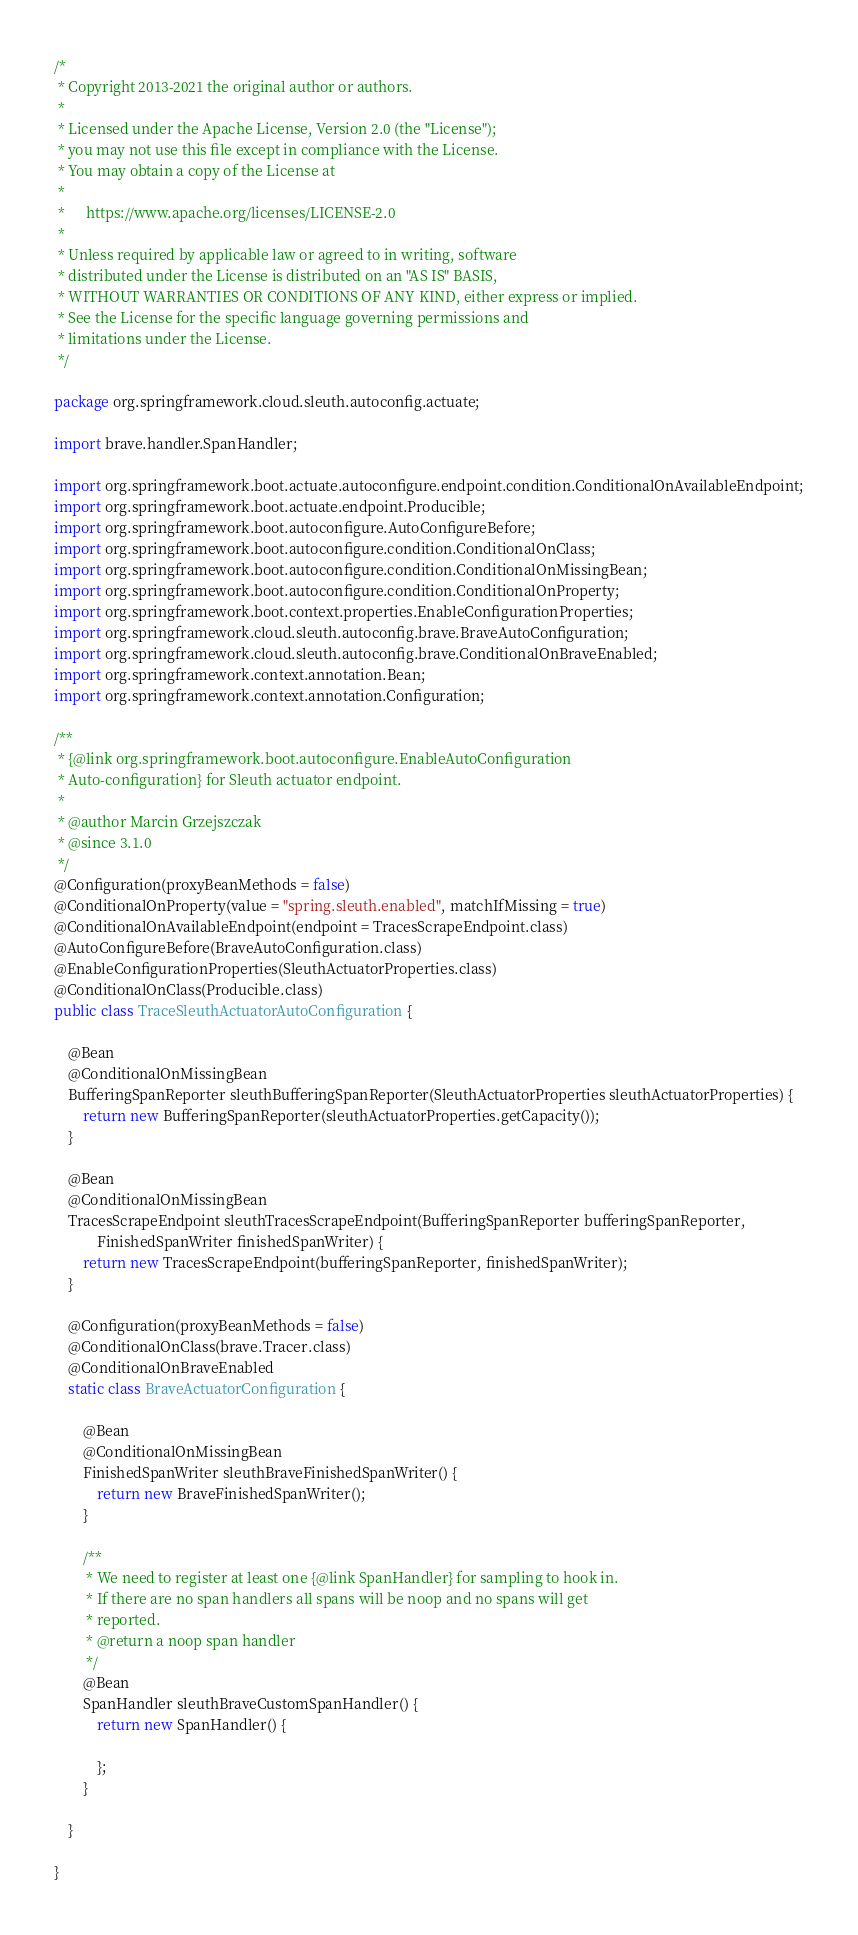Convert code to text. <code><loc_0><loc_0><loc_500><loc_500><_Java_>/*
 * Copyright 2013-2021 the original author or authors.
 *
 * Licensed under the Apache License, Version 2.0 (the "License");
 * you may not use this file except in compliance with the License.
 * You may obtain a copy of the License at
 *
 *      https://www.apache.org/licenses/LICENSE-2.0
 *
 * Unless required by applicable law or agreed to in writing, software
 * distributed under the License is distributed on an "AS IS" BASIS,
 * WITHOUT WARRANTIES OR CONDITIONS OF ANY KIND, either express or implied.
 * See the License for the specific language governing permissions and
 * limitations under the License.
 */

package org.springframework.cloud.sleuth.autoconfig.actuate;

import brave.handler.SpanHandler;

import org.springframework.boot.actuate.autoconfigure.endpoint.condition.ConditionalOnAvailableEndpoint;
import org.springframework.boot.actuate.endpoint.Producible;
import org.springframework.boot.autoconfigure.AutoConfigureBefore;
import org.springframework.boot.autoconfigure.condition.ConditionalOnClass;
import org.springframework.boot.autoconfigure.condition.ConditionalOnMissingBean;
import org.springframework.boot.autoconfigure.condition.ConditionalOnProperty;
import org.springframework.boot.context.properties.EnableConfigurationProperties;
import org.springframework.cloud.sleuth.autoconfig.brave.BraveAutoConfiguration;
import org.springframework.cloud.sleuth.autoconfig.brave.ConditionalOnBraveEnabled;
import org.springframework.context.annotation.Bean;
import org.springframework.context.annotation.Configuration;

/**
 * {@link org.springframework.boot.autoconfigure.EnableAutoConfiguration
 * Auto-configuration} for Sleuth actuator endpoint.
 *
 * @author Marcin Grzejszczak
 * @since 3.1.0
 */
@Configuration(proxyBeanMethods = false)
@ConditionalOnProperty(value = "spring.sleuth.enabled", matchIfMissing = true)
@ConditionalOnAvailableEndpoint(endpoint = TracesScrapeEndpoint.class)
@AutoConfigureBefore(BraveAutoConfiguration.class)
@EnableConfigurationProperties(SleuthActuatorProperties.class)
@ConditionalOnClass(Producible.class)
public class TraceSleuthActuatorAutoConfiguration {

	@Bean
	@ConditionalOnMissingBean
	BufferingSpanReporter sleuthBufferingSpanReporter(SleuthActuatorProperties sleuthActuatorProperties) {
		return new BufferingSpanReporter(sleuthActuatorProperties.getCapacity());
	}

	@Bean
	@ConditionalOnMissingBean
	TracesScrapeEndpoint sleuthTracesScrapeEndpoint(BufferingSpanReporter bufferingSpanReporter,
			FinishedSpanWriter finishedSpanWriter) {
		return new TracesScrapeEndpoint(bufferingSpanReporter, finishedSpanWriter);
	}

	@Configuration(proxyBeanMethods = false)
	@ConditionalOnClass(brave.Tracer.class)
	@ConditionalOnBraveEnabled
	static class BraveActuatorConfiguration {

		@Bean
		@ConditionalOnMissingBean
		FinishedSpanWriter sleuthBraveFinishedSpanWriter() {
			return new BraveFinishedSpanWriter();
		}

		/**
		 * We need to register at least one {@link SpanHandler} for sampling to hook in.
		 * If there are no span handlers all spans will be noop and no spans will get
		 * reported.
		 * @return a noop span handler
		 */
		@Bean
		SpanHandler sleuthBraveCustomSpanHandler() {
			return new SpanHandler() {

			};
		}

	}

}
</code> 